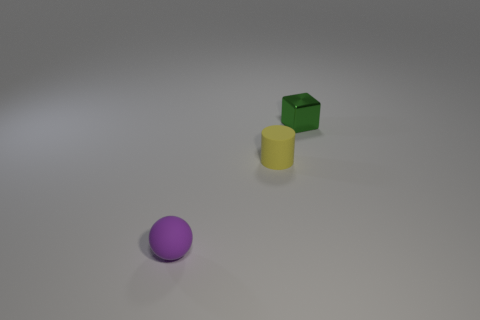Add 1 purple rubber balls. How many objects exist? 4 Subtract all spheres. How many objects are left? 2 Add 3 tiny yellow rubber things. How many tiny yellow rubber things exist? 4 Subtract 0 blue balls. How many objects are left? 3 Subtract all tiny green shiny balls. Subtract all tiny rubber things. How many objects are left? 1 Add 1 green blocks. How many green blocks are left? 2 